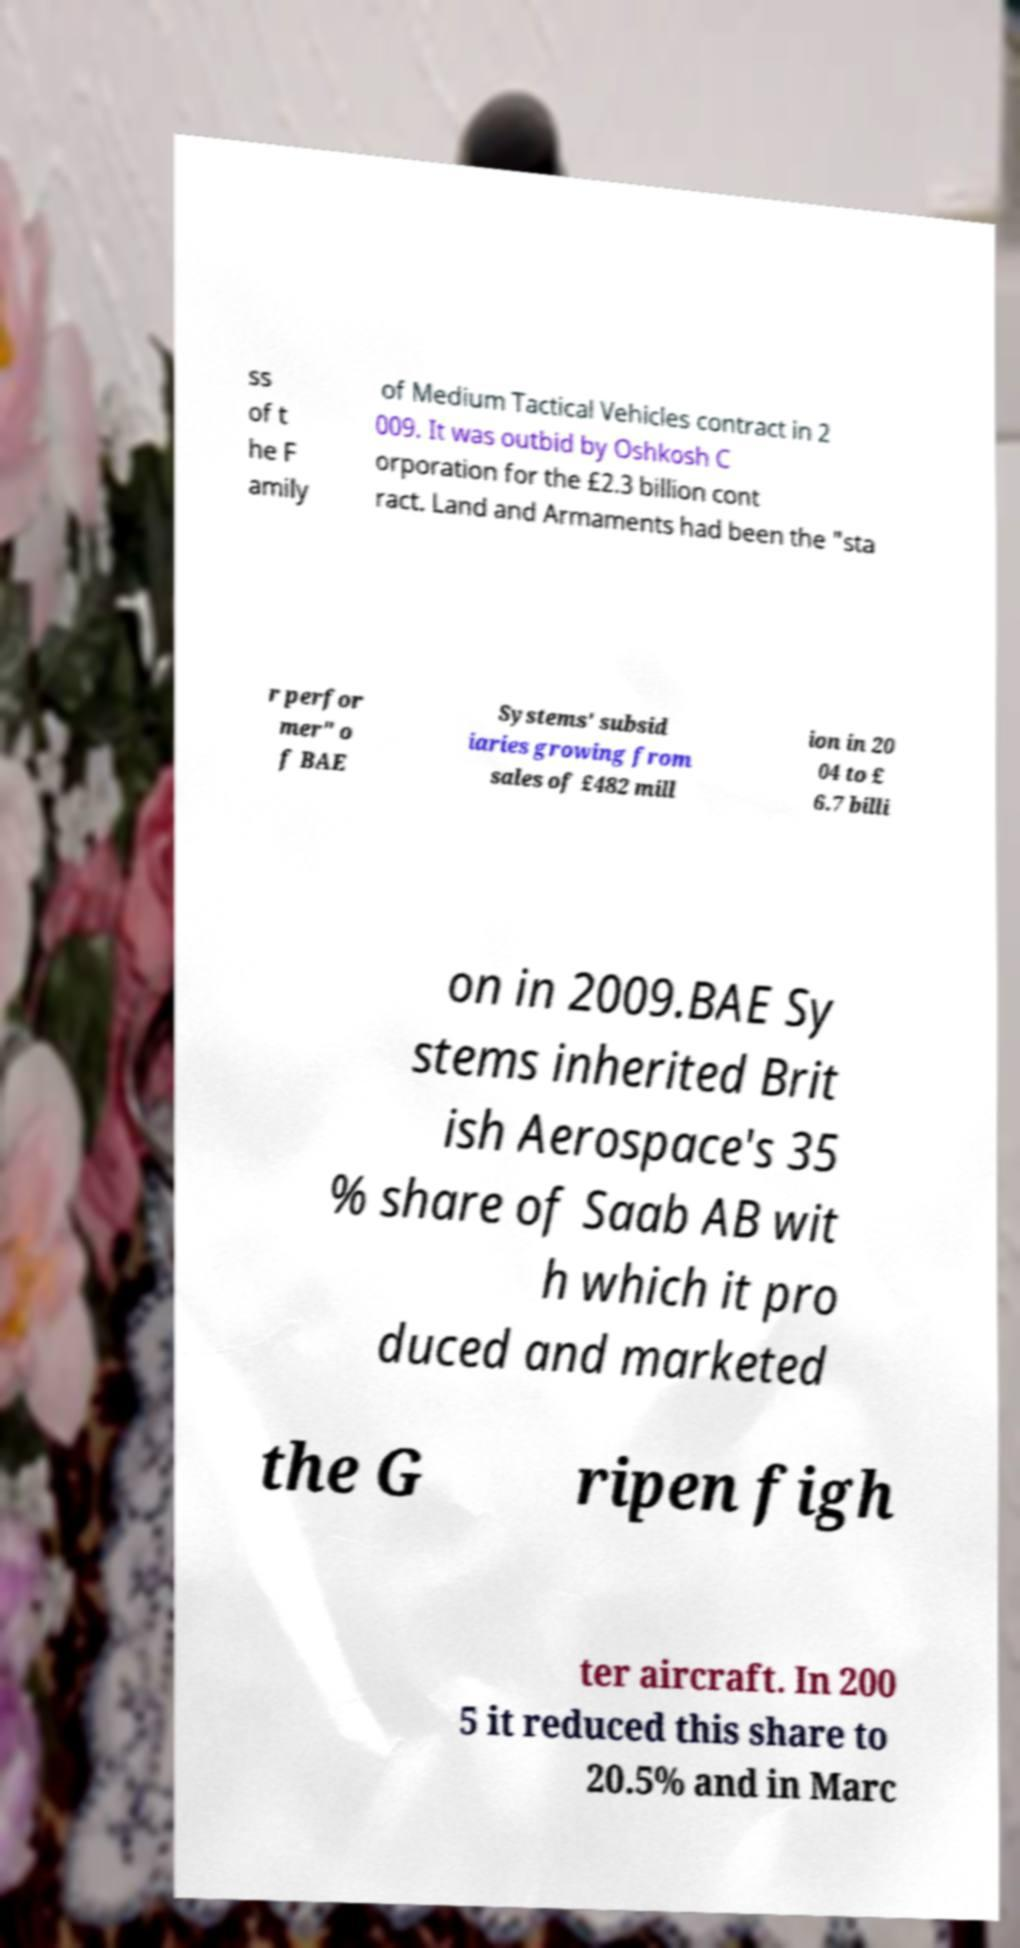For documentation purposes, I need the text within this image transcribed. Could you provide that? ss of t he F amily of Medium Tactical Vehicles contract in 2 009. It was outbid by Oshkosh C orporation for the £2.3 billion cont ract. Land and Armaments had been the "sta r perfor mer" o f BAE Systems' subsid iaries growing from sales of £482 mill ion in 20 04 to £ 6.7 billi on in 2009.BAE Sy stems inherited Brit ish Aerospace's 35 % share of Saab AB wit h which it pro duced and marketed the G ripen figh ter aircraft. In 200 5 it reduced this share to 20.5% and in Marc 